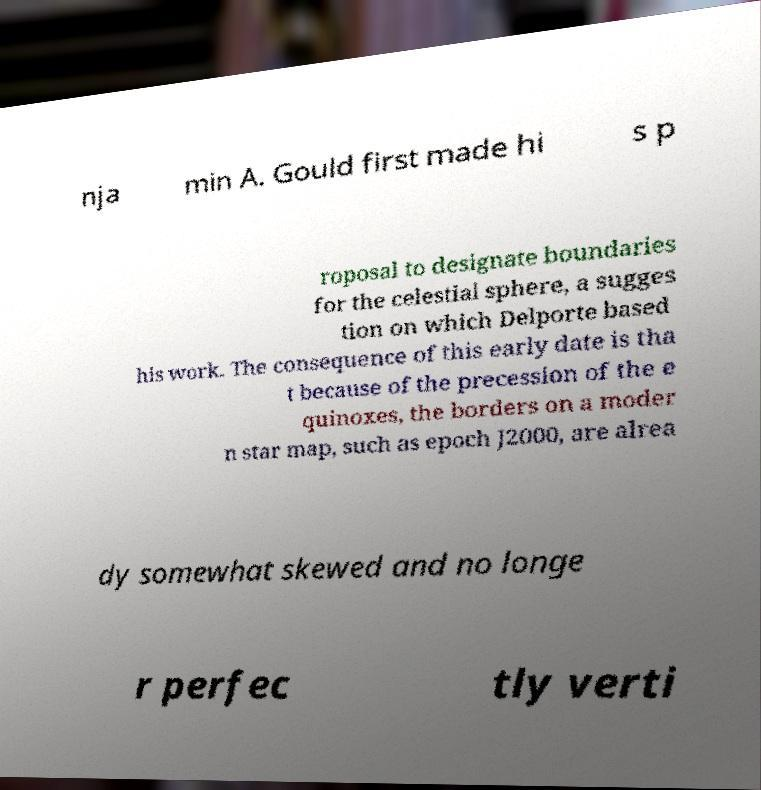Could you assist in decoding the text presented in this image and type it out clearly? nja min A. Gould first made hi s p roposal to designate boundaries for the celestial sphere, a sugges tion on which Delporte based his work. The consequence of this early date is tha t because of the precession of the e quinoxes, the borders on a moder n star map, such as epoch J2000, are alrea dy somewhat skewed and no longe r perfec tly verti 